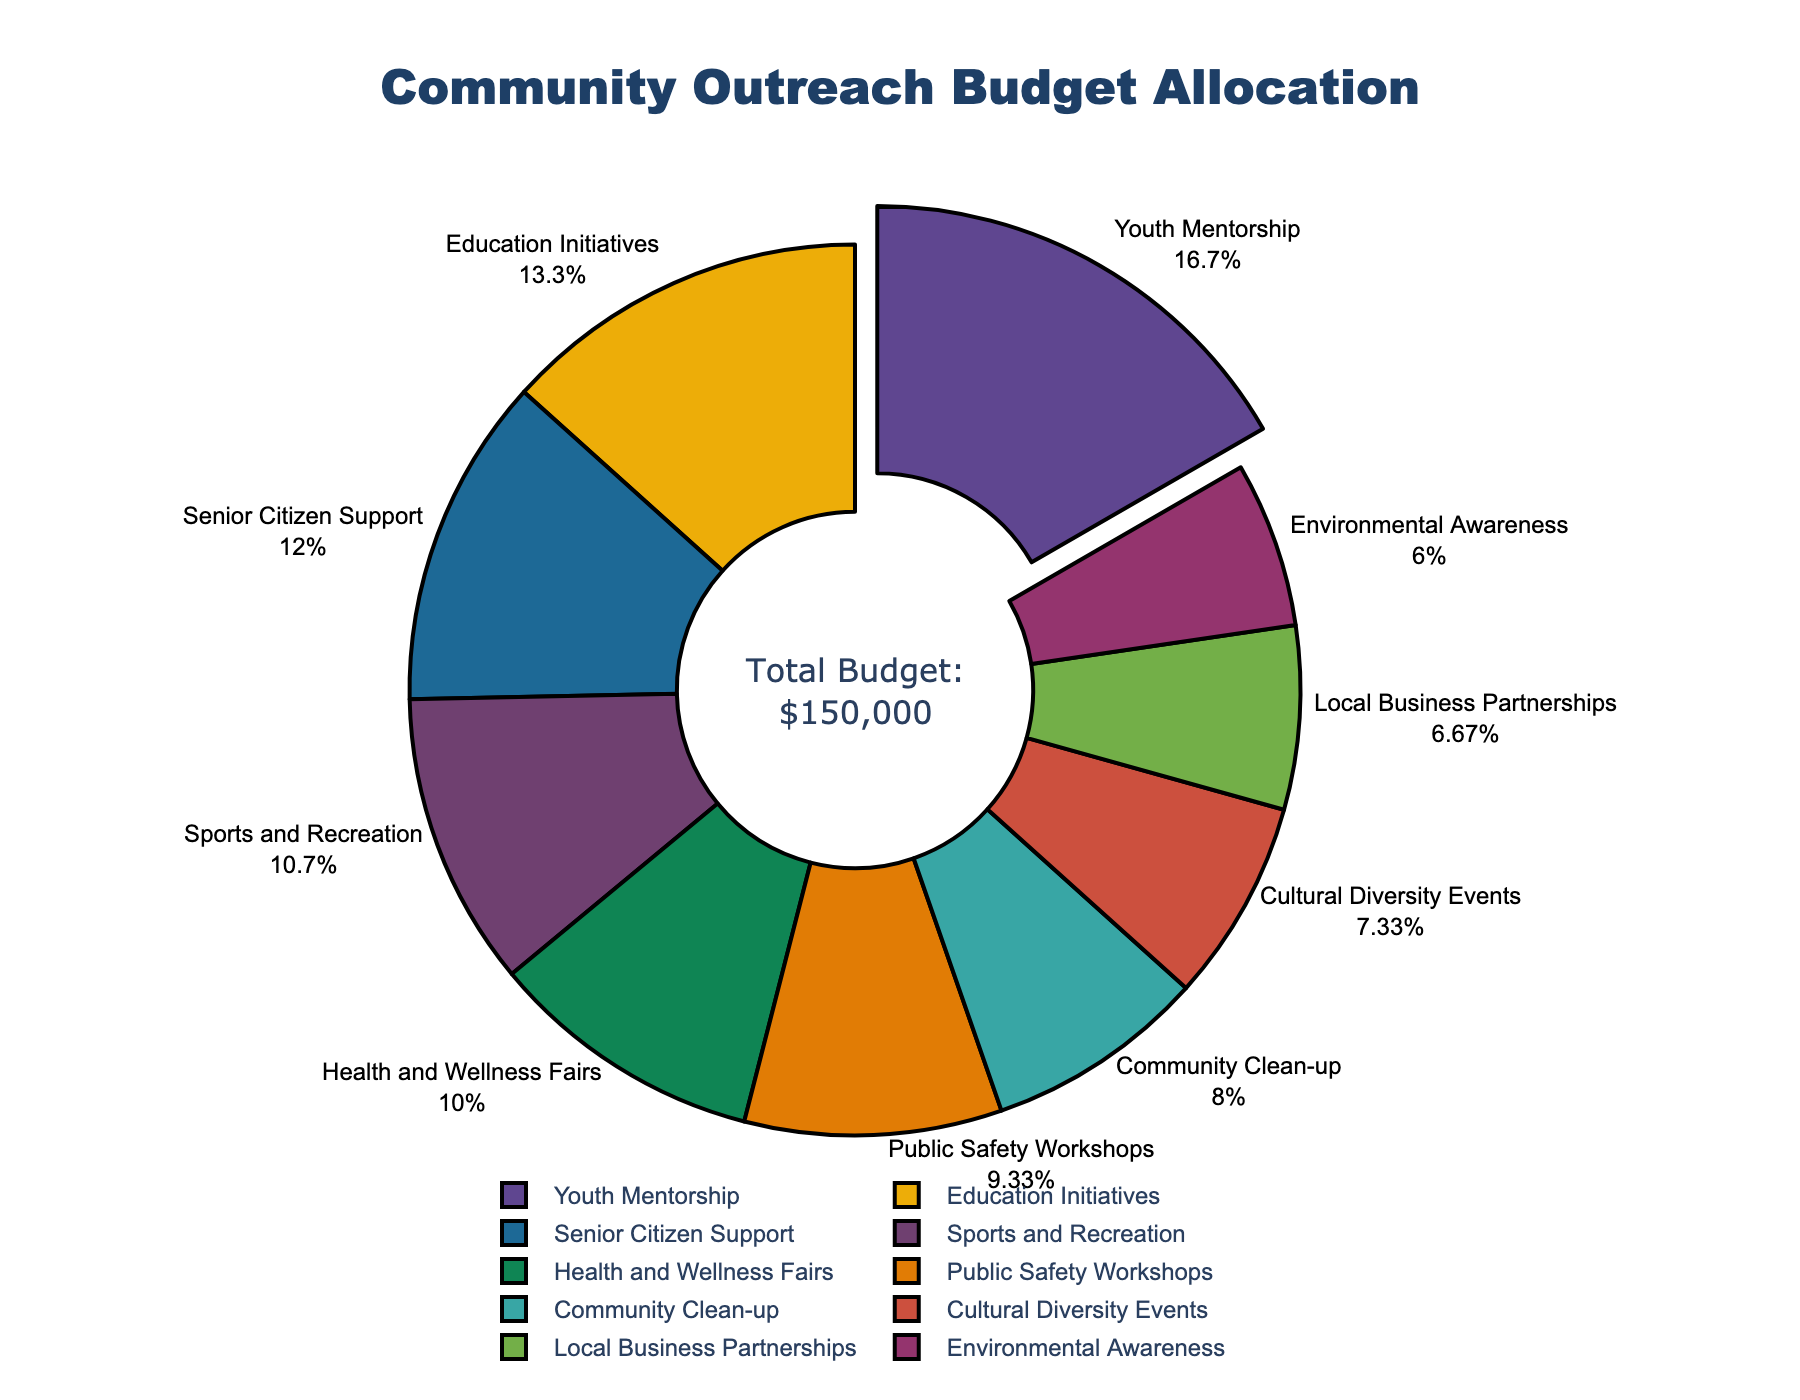Which program receives the highest budget allocation? Referring to the figure, the Youth Mentorship program stands out as the largest slice with a pulled-out effect, indicating it has the highest budget allocation.
Answer: Youth Mentorship Which program has the lowest budget allocation, and what percentage does it account for? The Environmental Awareness program has the smallest slice in the figure, representing the lowest budget allocation. The percentage displayed outside this slice is 6%.
Answer: Environmental Awareness, 6% What is the combined budget allocation for Health and Wellness Fairs and Sports and Recreation? The budget allocation for Health and Wellness Fairs is $15,000 and for Sports and Recreation is $16,000. Adding these amounts, $15,000 + $16,000 = $31,000.
Answer: $31,000 How does the budget for Cultural Diversity Events compare to that of Community Clean-up? The budget for Cultural Diversity Events is $11,000, which is higher than the $12,000 allocation for Community Clean-up.
Answer: Cultural Diversity Events < Community Clean-up What percentage of the total budget is allocated to Education Initiatives, and how does it compare to Sports and Recreation? The figure shows Education Initiatives at 13%. The Sports and Recreation budget is 11%. Education Initiatives has a higher percentage of the total budget than Sports and Recreation.
Answer: 13%, more What is the total budget allocated to programs directly benefiting specific age groups (Youth Mentorship and Senior Citizen Support)? The budget allocation for Youth Mentorship is $25,000 and for Senior Citizen Support is $18,000. Adding these values together, $25,000 + $18,000 = $43,000.
Answer: $43,000 List the programs with a budget allocation greater than $15,000, and provide their percentages. By inspecting the figure, the programs with allocations greater than $15,000 are Youth Mentorship (17%), Education Initiatives (13%), and Senior Citizen Support (12%).
Answer: Youth Mentorship (17%), Education Initiatives (13%), Senior Citizen Support (12%) What is the average budget allocation across all programs? Summing all the budget allocations yields a total of $150,000. There are 10 programs. Therefore, the average allocation is $150,000 / 10 = $15,000.
Answer: $15,000 Which program aligns closest to the average budget allocation? The average budget allocation is $15,000. The program that exactly matches this average is Health and Wellness Fairs, which has an allocation of $15,000.
Answer: Health and Wellness Fairs 